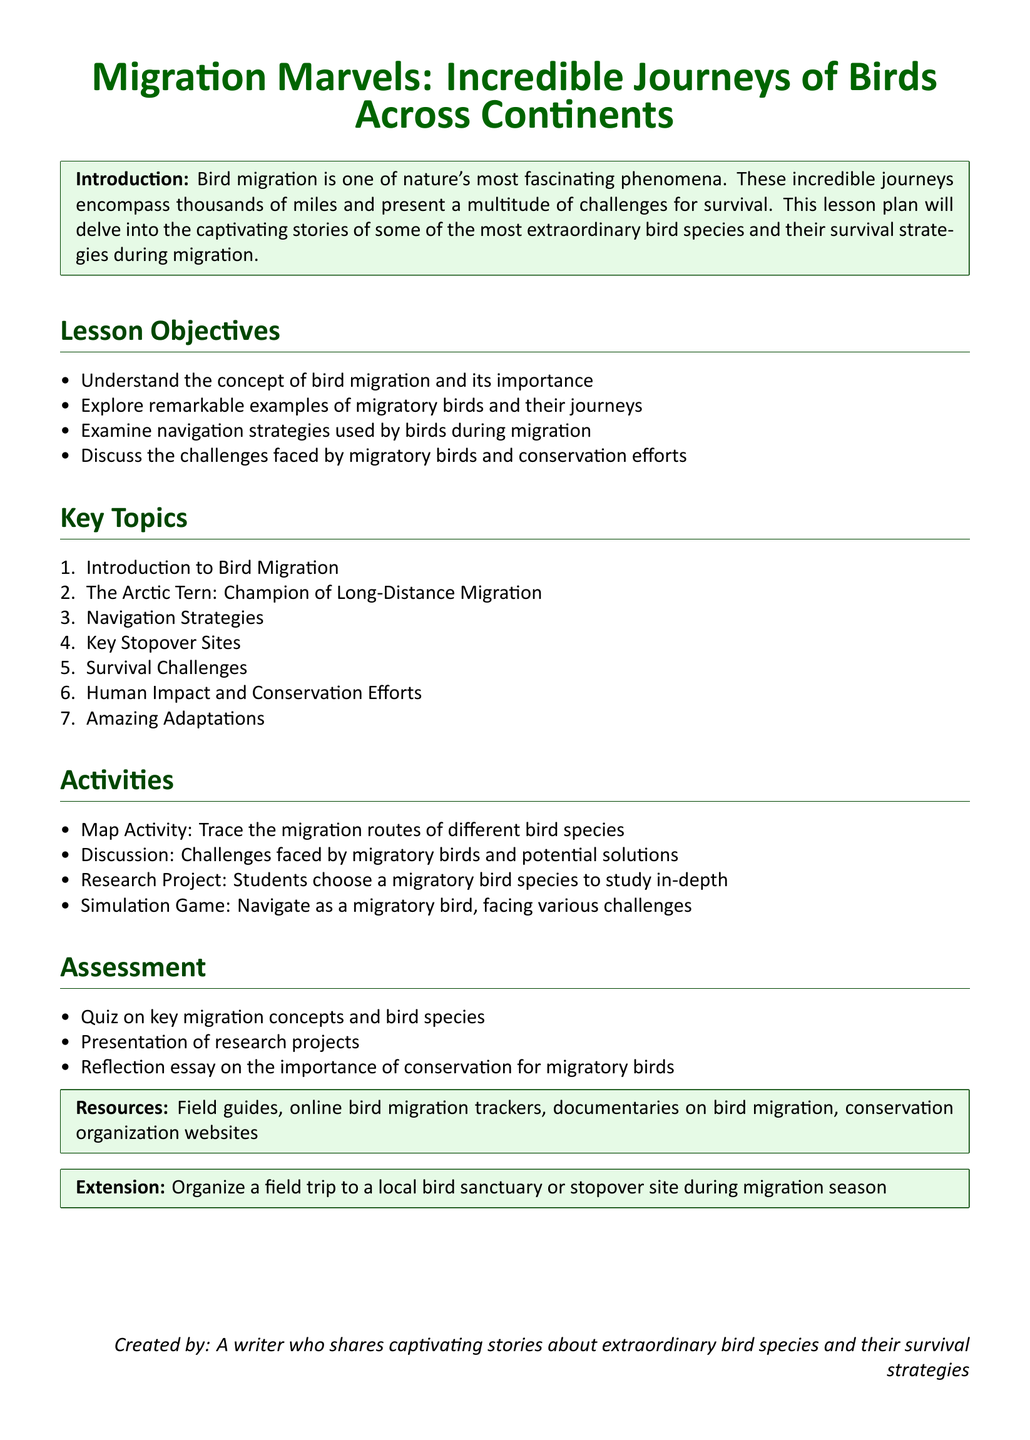what is the title of the lesson plan? The title of the lesson plan is the main heading at the top of the document, indicating the focus of the content.
Answer: Migration Marvels: Incredible Journeys of Birds Across Continents what are the lesson objectives? The lesson objectives are explicitly listed in the document to outline the intended outcomes of the lesson.
Answer: Understand the concept of bird migration and its importance, Explore remarkable examples of migratory birds and their journeys, Examine navigation strategies used by birds during migration, Discuss the challenges faced by migratory birds and conservation efforts who is the champion of long-distance migration mentioned in the document? The document names a specific bird recognized for its long migration distance, which is an important topic covered.
Answer: Arctic Tern how many assessment methods are listed in the document? The document provides a count of the various methods employed to assess understanding at the end of the lesson plan.
Answer: Three what activity involves tracing migration routes? The document specifies a particular activity that helps students engage with the concept of migration through a practical exercise.
Answer: Map Activity what key topic relates to the impact of humans on migratory birds? The document includes a topic that addresses how human activities affect migratory birds, highlighting conservation issues.
Answer: Human Impact and Conservation Efforts what resource type is mentioned for studying bird migration? The document mentions a specific type of material that can be used for students to learn about bird migration effectively.
Answer: Field guides what extension activity is suggested in the lesson plan? The document describes an additional activity that extends the learning experience beyond the classroom.
Answer: Organize a field trip to a local bird sanctuary or stopover site during migration season 